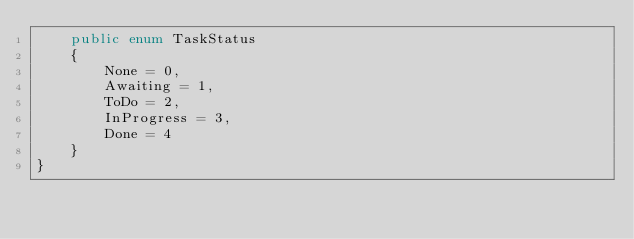<code> <loc_0><loc_0><loc_500><loc_500><_C#_>    public enum TaskStatus
    {
        None = 0,
        Awaiting = 1,
        ToDo = 2,
        InProgress = 3,
        Done = 4
    }
}</code> 